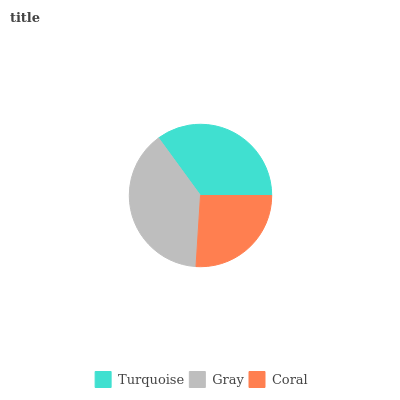Is Coral the minimum?
Answer yes or no. Yes. Is Gray the maximum?
Answer yes or no. Yes. Is Gray the minimum?
Answer yes or no. No. Is Coral the maximum?
Answer yes or no. No. Is Gray greater than Coral?
Answer yes or no. Yes. Is Coral less than Gray?
Answer yes or no. Yes. Is Coral greater than Gray?
Answer yes or no. No. Is Gray less than Coral?
Answer yes or no. No. Is Turquoise the high median?
Answer yes or no. Yes. Is Turquoise the low median?
Answer yes or no. Yes. Is Coral the high median?
Answer yes or no. No. Is Gray the low median?
Answer yes or no. No. 